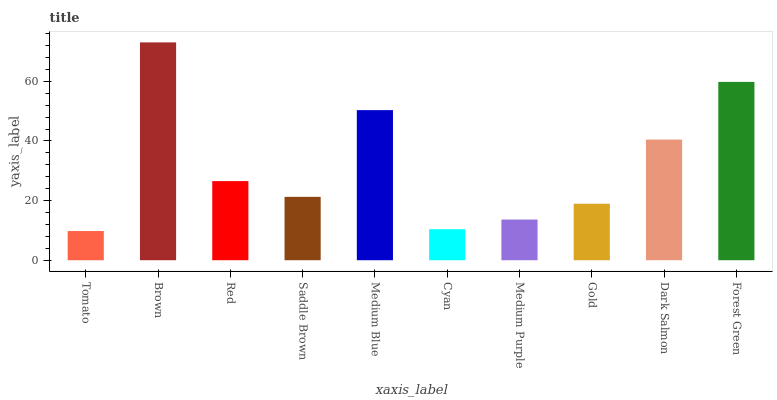Is Tomato the minimum?
Answer yes or no. Yes. Is Brown the maximum?
Answer yes or no. Yes. Is Red the minimum?
Answer yes or no. No. Is Red the maximum?
Answer yes or no. No. Is Brown greater than Red?
Answer yes or no. Yes. Is Red less than Brown?
Answer yes or no. Yes. Is Red greater than Brown?
Answer yes or no. No. Is Brown less than Red?
Answer yes or no. No. Is Red the high median?
Answer yes or no. Yes. Is Saddle Brown the low median?
Answer yes or no. Yes. Is Medium Blue the high median?
Answer yes or no. No. Is Red the low median?
Answer yes or no. No. 